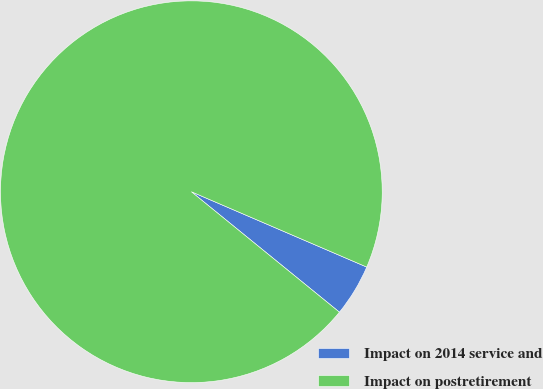Convert chart. <chart><loc_0><loc_0><loc_500><loc_500><pie_chart><fcel>Impact on 2014 service and<fcel>Impact on postretirement<nl><fcel>4.41%<fcel>95.59%<nl></chart> 